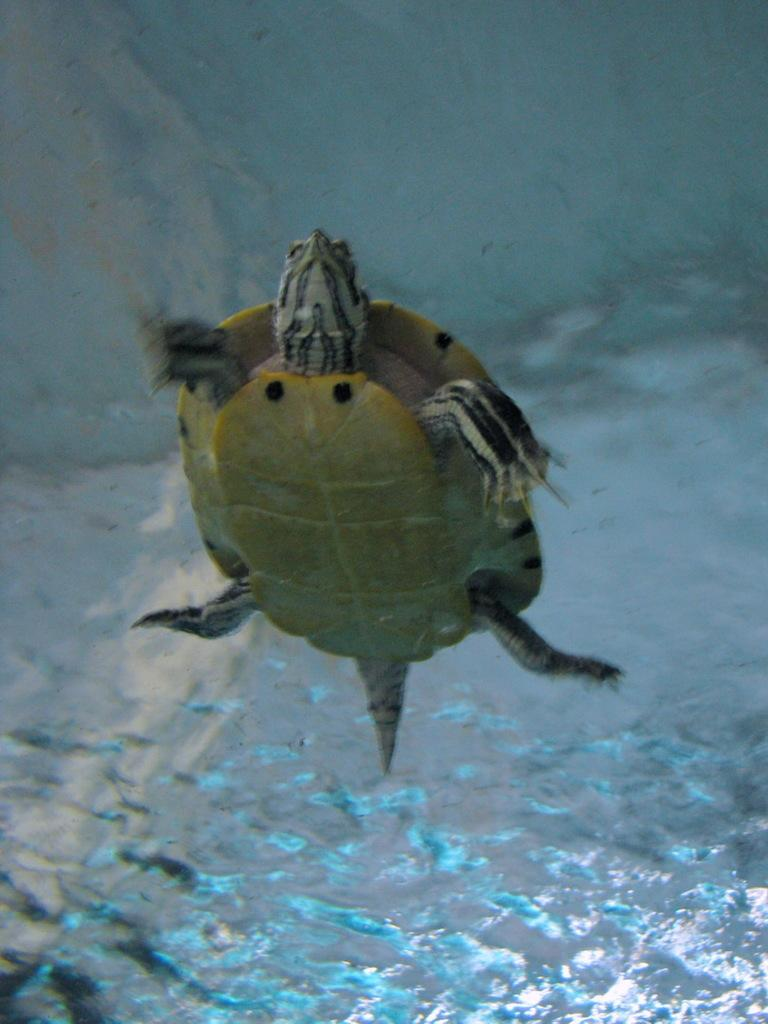What type of animal is in the image? There is a tortoise in the image. Where is the tortoise located? The tortoise is in water. What type of care does the daughter provide for the bat in the image? There is no daughter or bat present in the image; it features a tortoise in water. 